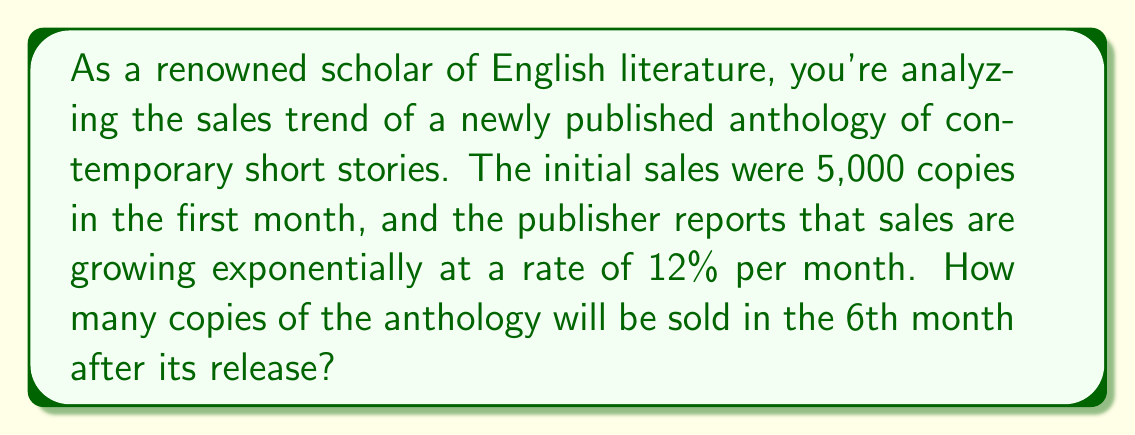What is the answer to this math problem? Let's approach this step-by-step using an exponential growth function:

1) The general form of an exponential growth function is:
   $A(t) = A_0(1 + r)^t$
   where $A(t)$ is the amount at time $t$, $A_0$ is the initial amount, $r$ is the growth rate, and $t$ is the time period.

2) In this case:
   $A_0 = 5,000$ (initial sales)
   $r = 0.12$ (12% growth rate)
   $t = 5$ (we want the 6th month, which is 5 months after the initial month)

3) Plugging these values into our equation:
   $A(5) = 5,000(1 + 0.12)^5$

4) Simplify inside the parentheses:
   $A(5) = 5,000(1.12)^5$

5) Calculate the exponent:
   $(1.12)^5 \approx 1.7623$

6) Multiply:
   $A(5) = 5,000 * 1.7623 \approx 8,811.5$

7) Since we can't sell partial books, we round to the nearest whole number:
   $A(5) \approx 8,812$

Therefore, approximately 8,812 copies of the anthology will be sold in the 6th month.
Answer: 8,812 copies 